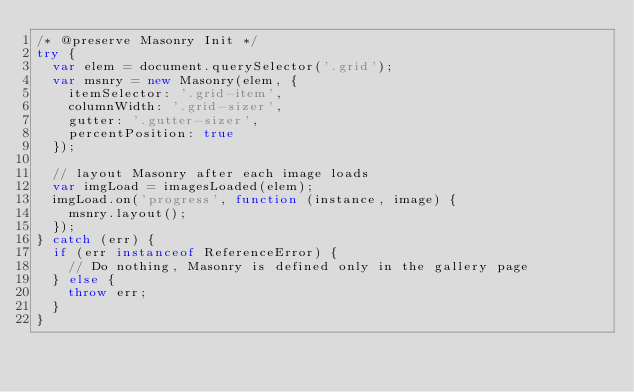<code> <loc_0><loc_0><loc_500><loc_500><_JavaScript_>/* @preserve Masonry Init */
try {
  var elem = document.querySelector('.grid');
  var msnry = new Masonry(elem, {
    itemSelector: '.grid-item',
    columnWidth: '.grid-sizer',
    gutter: '.gutter-sizer',
    percentPosition: true
  });

  // layout Masonry after each image loads
  var imgLoad = imagesLoaded(elem);
  imgLoad.on('progress', function (instance, image) {
    msnry.layout();
  });
} catch (err) {
  if (err instanceof ReferenceError) {
    // Do nothing, Masonry is defined only in the gallery page
  } else {
    throw err;
  }
}
</code> 